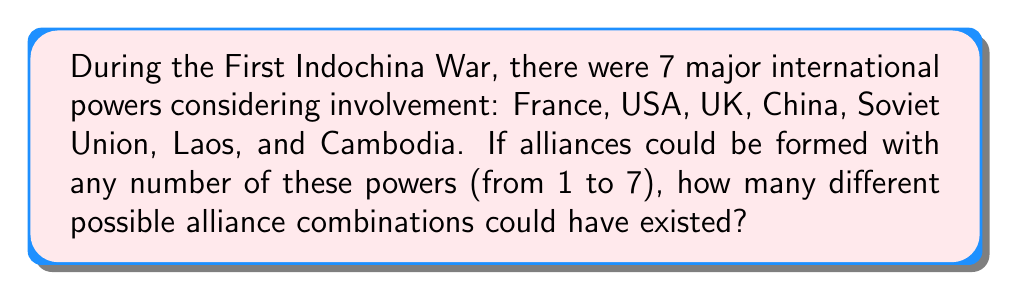Can you answer this question? Let's approach this step-by-step:

1) This is a combination problem where we need to consider all possible groupings of the 7 powers.

2) For each power, we have two choices: it's either in the alliance or not.

3) This scenario is perfectly suited for the power set formula. The power set of a set with n elements has $2^n$ subsets.

4) In this case, we have 7 powers, so n = 7.

5) Therefore, the number of possible alliances is $2^7$.

6) We can calculate this:

   $$2^7 = 2 \times 2 \times 2 \times 2 \times 2 \times 2 \times 2 = 128$$

7) However, we need to subtract 1 from this total because the empty set (no alliance) is not a valid option in this context.

8) Thus, the final answer is $2^7 - 1 = 128 - 1 = 127$.
Answer: $127$ 